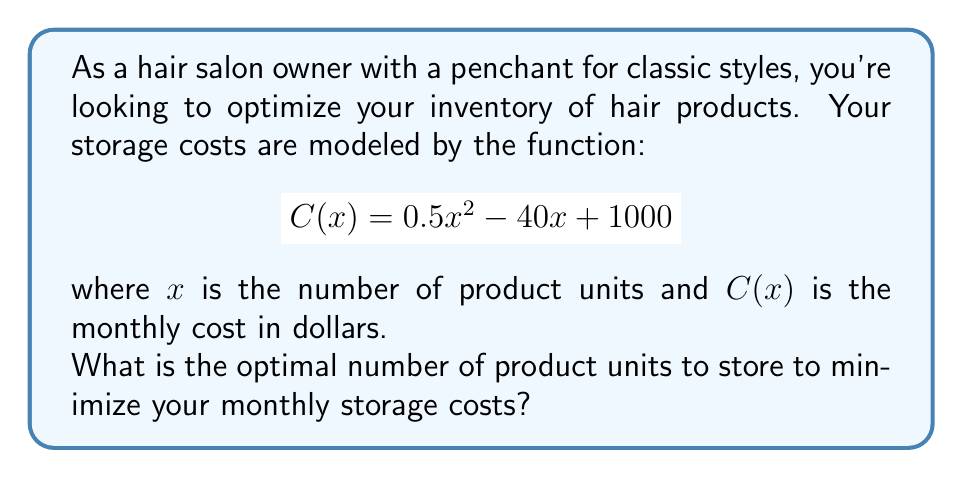Provide a solution to this math problem. To find the optimal number of product units that minimizes the storage costs, we need to find the minimum point of the cost function $C(x)$. This can be done using differential calculus:

1) First, we find the derivative of the cost function:
   $$C'(x) = \frac{d}{dx}(0.5x^2 - 40x + 1000) = x - 40$$

2) To find the minimum point, we set the derivative equal to zero and solve for x:
   $$C'(x) = 0$$
   $$x - 40 = 0$$
   $$x = 40$$

3) To confirm this is a minimum (not a maximum), we can check the second derivative:
   $$C''(x) = \frac{d}{dx}(x - 40) = 1$$
   
   Since $C''(x) > 0$, this confirms that $x = 40$ is indeed a minimum point.

4) Therefore, the optimal number of product units to store is 40.

5) We can verify this by calculating the cost at this point:
   $$C(40) = 0.5(40)^2 - 40(40) + 1000 = 800 - 1600 + 1000 = 200$$

   This is indeed the lowest point on the cost curve.
Answer: 40 units 